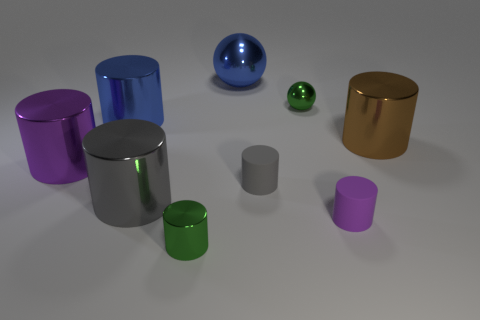Subtract 1 cylinders. How many cylinders are left? 6 Subtract all brown cylinders. How many cylinders are left? 6 Subtract all brown cylinders. How many cylinders are left? 6 Subtract all brown cylinders. Subtract all gray blocks. How many cylinders are left? 6 Add 1 big purple metal cylinders. How many objects exist? 10 Subtract all balls. How many objects are left? 7 Add 6 purple matte objects. How many purple matte objects are left? 7 Add 4 small shiny cylinders. How many small shiny cylinders exist? 5 Subtract 0 purple balls. How many objects are left? 9 Subtract all blue metallic objects. Subtract all metal spheres. How many objects are left? 5 